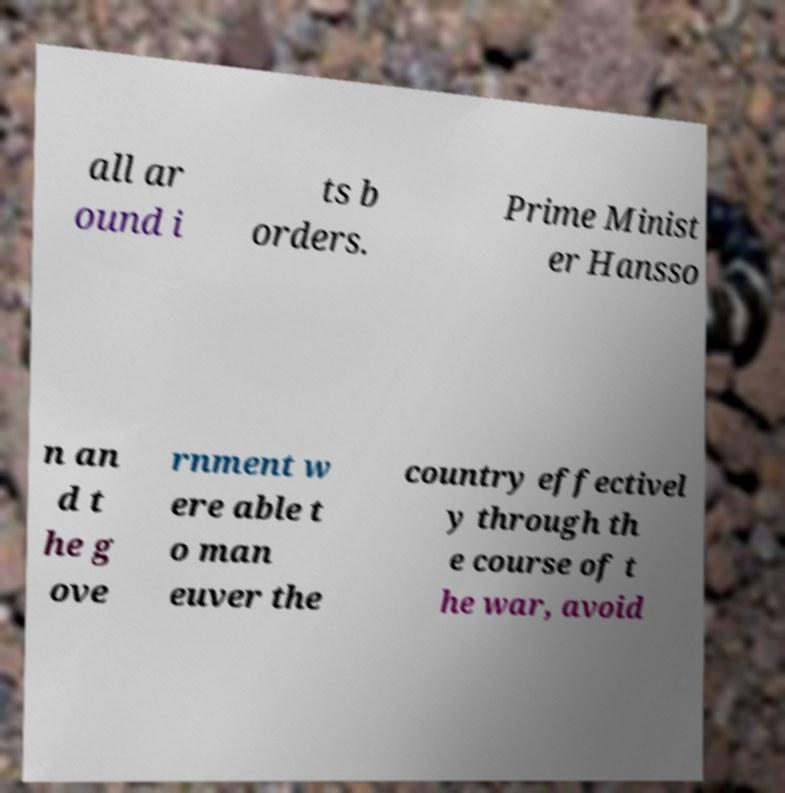Please identify and transcribe the text found in this image. all ar ound i ts b orders. Prime Minist er Hansso n an d t he g ove rnment w ere able t o man euver the country effectivel y through th e course of t he war, avoid 